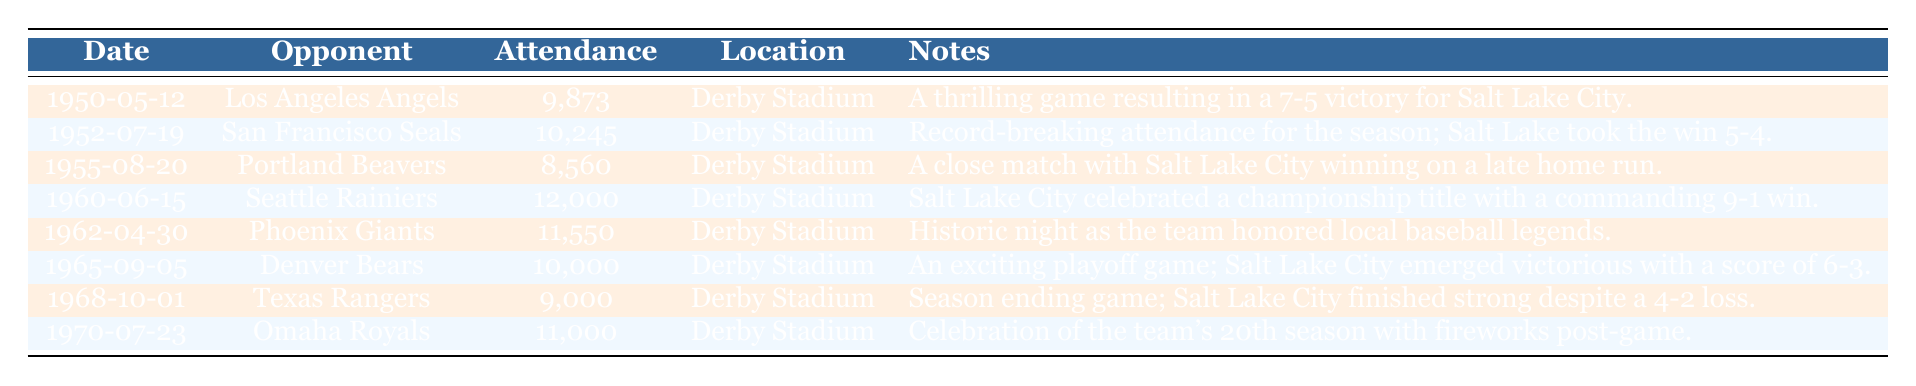What was the highest attendance recorded in a game from 1950 to 1970? By scanning the attendance column in the table, the highest value is 12,000, which occurred during the game against the Seattle Rainiers on June 15, 1960.
Answer: 12,000 Which game had the lowest attendance? The attendance data shows that the lowest figure is 8,560, during the match against the Portland Beavers on August 20, 1955.
Answer: 8,560 How many games had an attendance of over 10,000? By examining the attendance numbers, there are four games that had attendance figures of over 10,000: 10,245, 12,000, 11,550, and 11,000.
Answer: 4 What was the average attendance over all games listed? The total attendance from all games is 9,873 + 10,245 + 8,560 + 12,000 + 11,550 + 10,000 + 9,000 + 11,000 = 82,228. There are 8 games, so the average attendance is 82,228 / 8 = 10,278.5.
Answer: 10,278.5 Did Salt Lake City win every game listed in the table? By reading the notes for each game, we find that Salt Lake City won five games and lost three games (the losses were against Portland Beavers in 1955 and Texas Rangers in 1968).
Answer: No What was the score in the game with the highest attendance, and what was notable about that game? The highest attendance was 12,000 on June 15, 1960, against the Seattle Rainiers, where Salt Lake City won the game with a commanding score of 9-1.
Answer: 9-1, notable for winning by a large margin Which game was played to commemorate local baseball legends? The game against the Phoenix Giants on April 30, 1962, was noted for honoring local baseball legends.
Answer: Phoenix Giants on April 30, 1962 Was there a playoff game mentioned in the table? Yes, the game against the Denver Bears on September 5, 1965, was specified as an exciting playoff game in the notes.
Answer: Yes How many seasons did Salt Lake City celebrate by setting off fireworks according to this data? In the table, only one game mentions a celebration with fireworks, which was the match on July 23, 1970, against the Omaha Royals to celebrate the team’s 20th season.
Answer: 1 Which opponent had a game with the note indicating it was a close match? The opponent was the Portland Beavers, as described in the note for the game on August 20, 1955, stating Salt Lake City won on a late home run.
Answer: Portland Beavers 